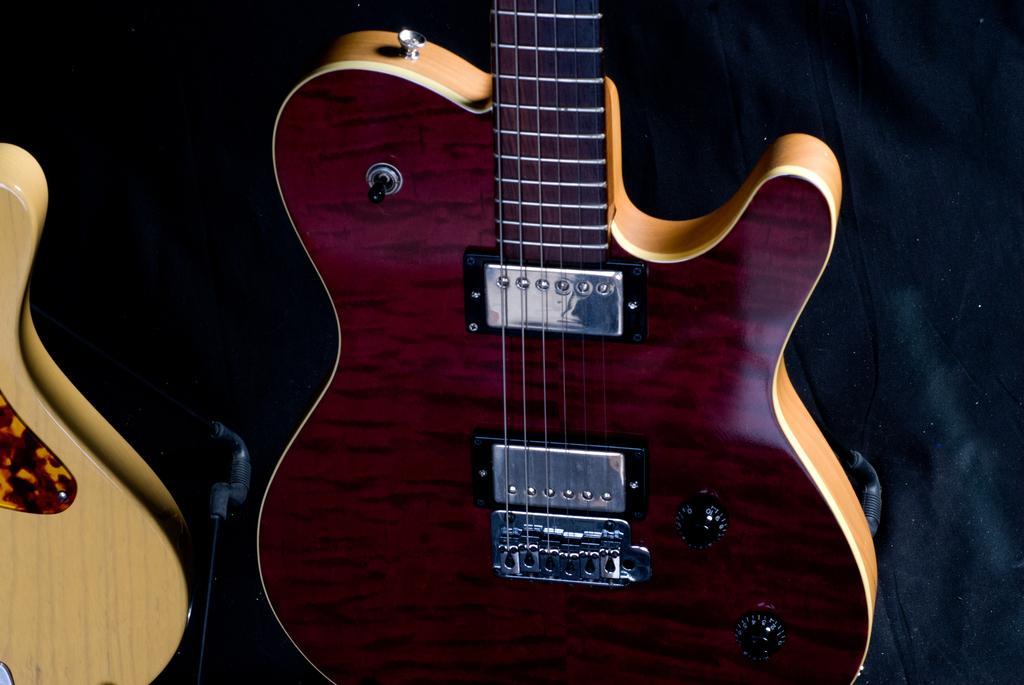Describe this image in one or two sentences. This picture shows a pair of guitars. 